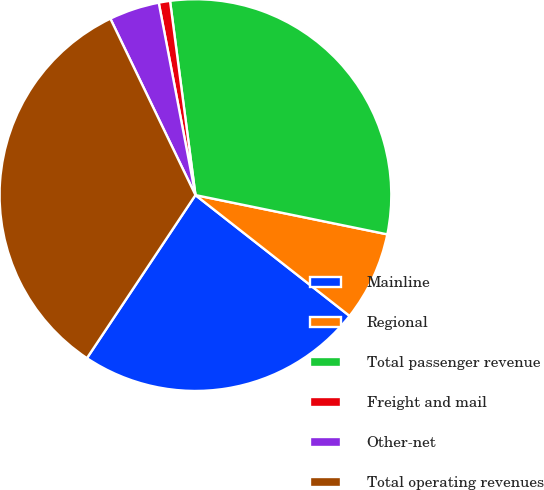Convert chart. <chart><loc_0><loc_0><loc_500><loc_500><pie_chart><fcel>Mainline<fcel>Regional<fcel>Total passenger revenue<fcel>Freight and mail<fcel>Other-net<fcel>Total operating revenues<nl><fcel>23.76%<fcel>7.37%<fcel>30.28%<fcel>0.93%<fcel>4.15%<fcel>33.5%<nl></chart> 